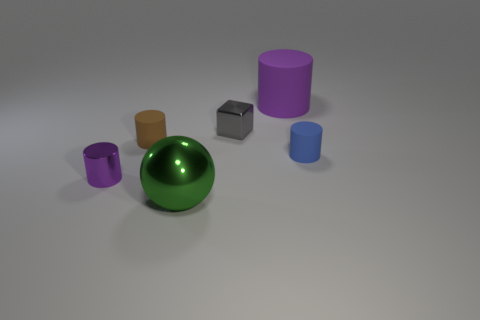The tiny purple shiny thing has what shape?
Offer a very short reply. Cylinder. What number of purple objects are spheres or big cylinders?
Ensure brevity in your answer.  1. There is a cube that is made of the same material as the tiny purple cylinder; what size is it?
Offer a very short reply. Small. Do the purple cylinder that is behind the small purple metal object and the small cylinder behind the blue cylinder have the same material?
Offer a very short reply. Yes. What number of cylinders are either tiny purple objects or brown matte things?
Offer a very short reply. 2. There is a purple matte cylinder on the right side of the gray thing that is to the right of the brown rubber cylinder; what number of purple metallic objects are behind it?
Your answer should be compact. 0. What material is the tiny brown thing that is the same shape as the big purple object?
Your answer should be very brief. Rubber. What color is the metallic object that is behind the purple metallic cylinder?
Your response must be concise. Gray. Do the small brown thing and the purple cylinder that is in front of the small brown thing have the same material?
Offer a terse response. No. What is the gray block made of?
Make the answer very short. Metal. 